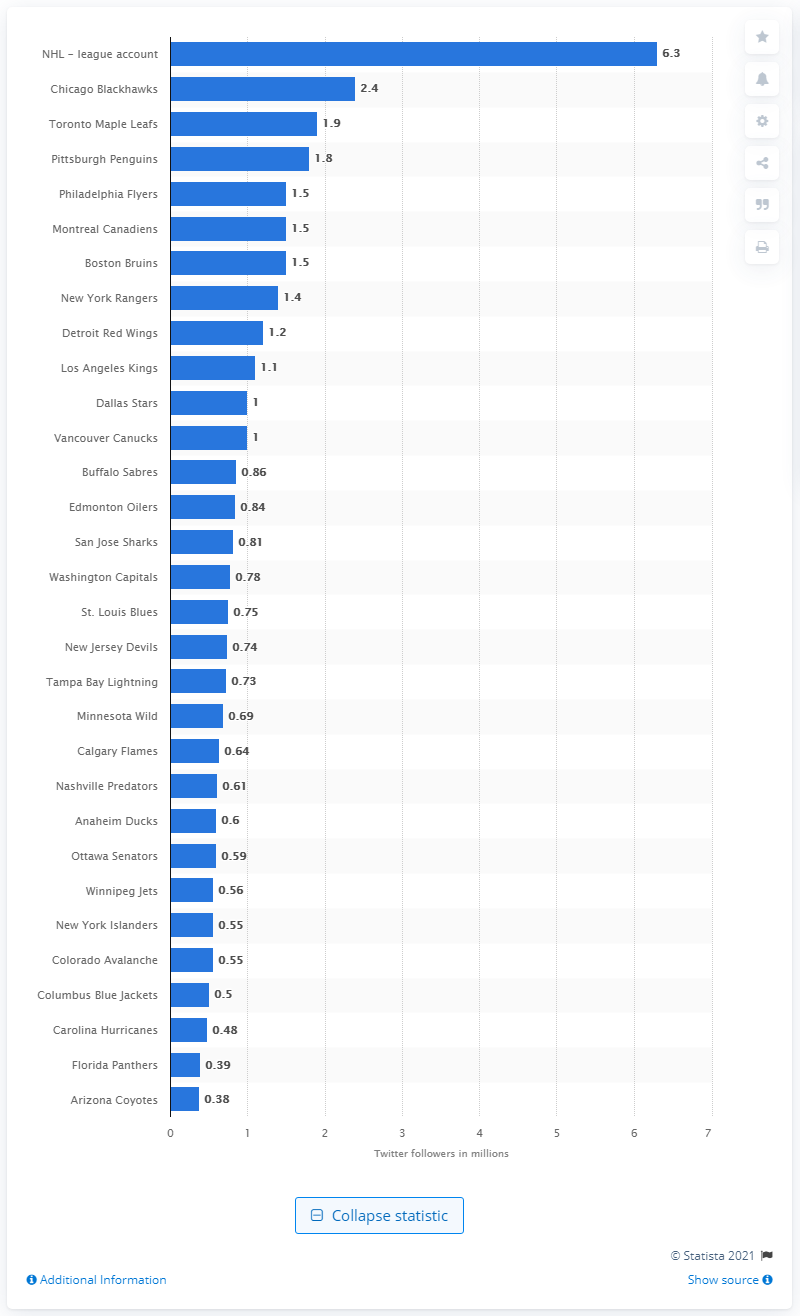Specify some key components in this picture. The Chicago Blackhawks have the most followers on Twitter among all teams. The NHL has 6.3 million followers on Twitter. 